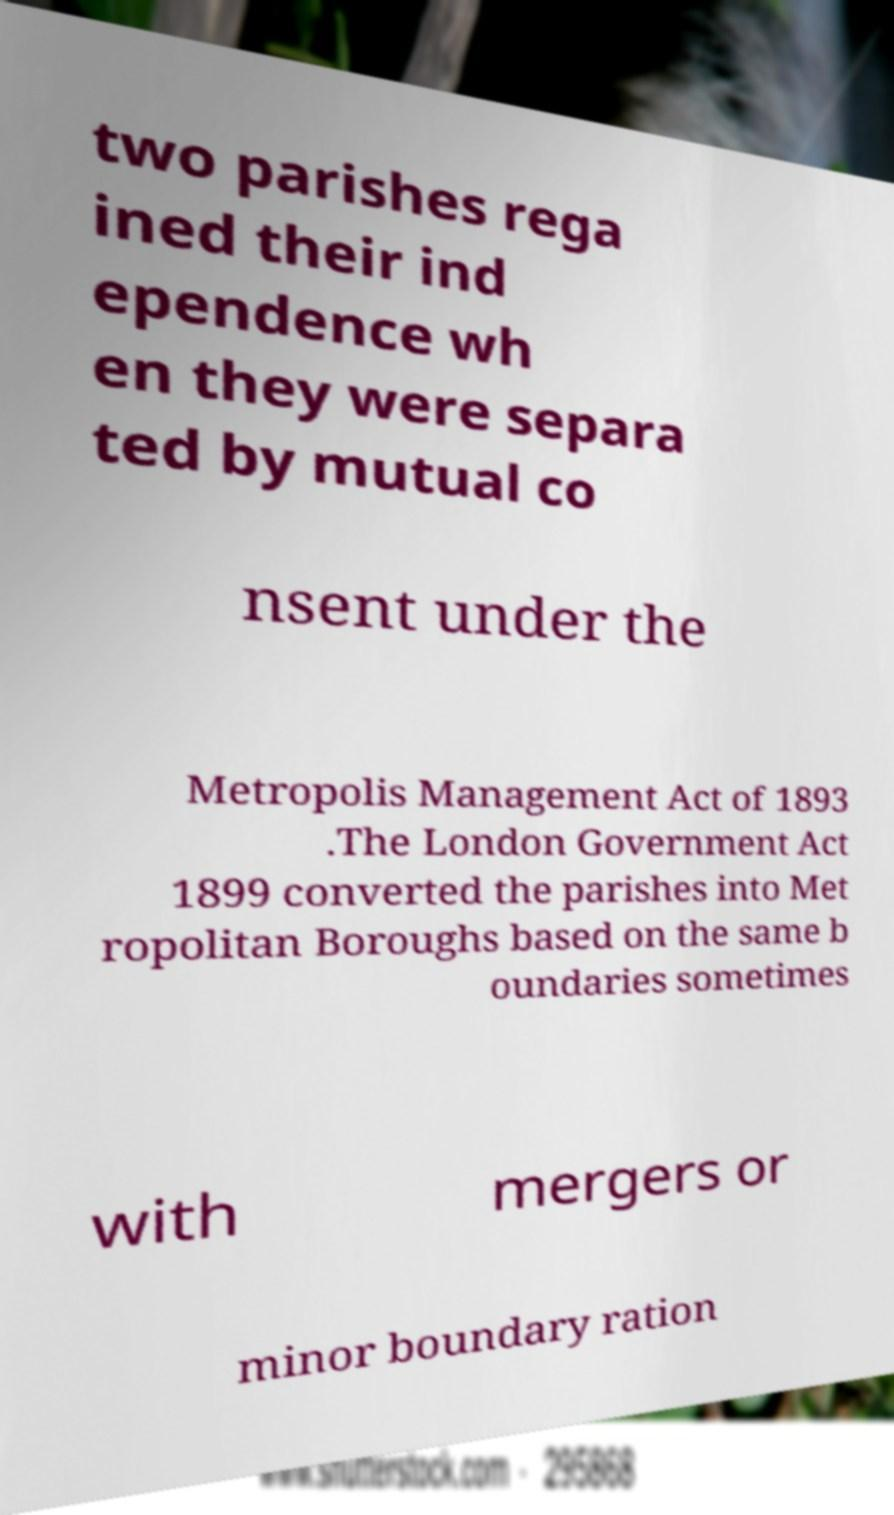Could you assist in decoding the text presented in this image and type it out clearly? two parishes rega ined their ind ependence wh en they were separa ted by mutual co nsent under the Metropolis Management Act of 1893 .The London Government Act 1899 converted the parishes into Met ropolitan Boroughs based on the same b oundaries sometimes with mergers or minor boundary ration 